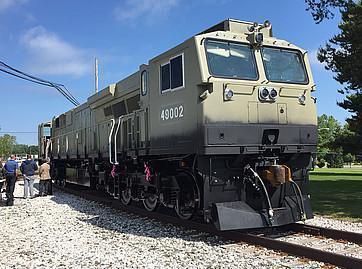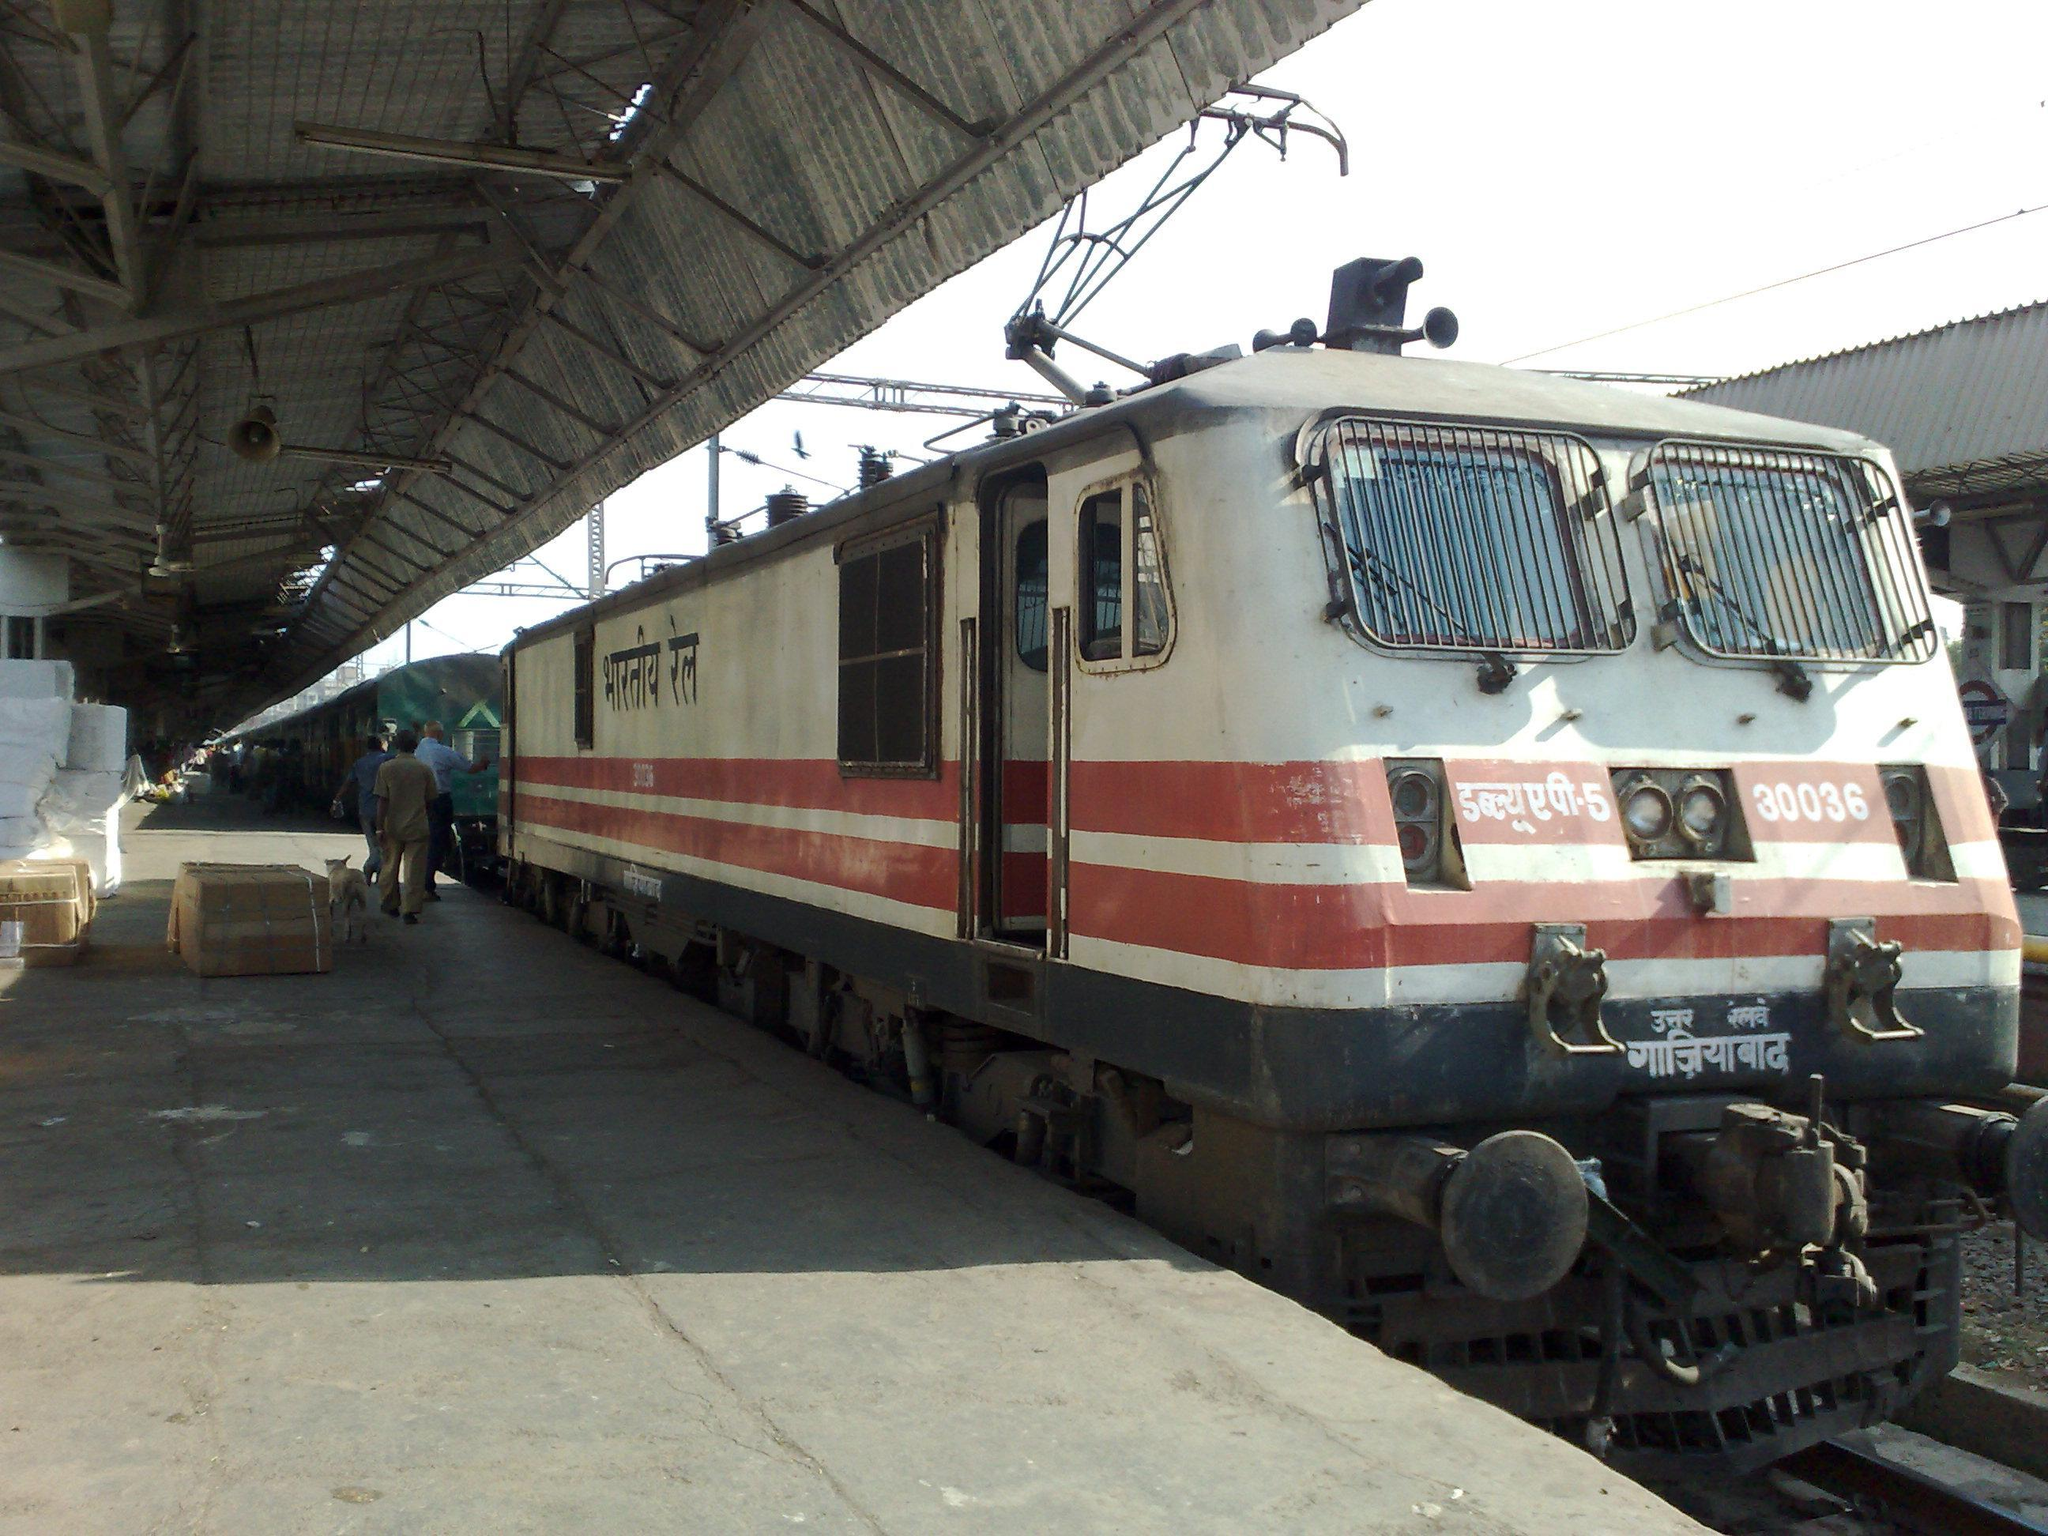The first image is the image on the left, the second image is the image on the right. For the images displayed, is the sentence "One train has a blue body and a white top that extends in an upside-down V-shape on the front of the train." factually correct? Answer yes or no. No. 